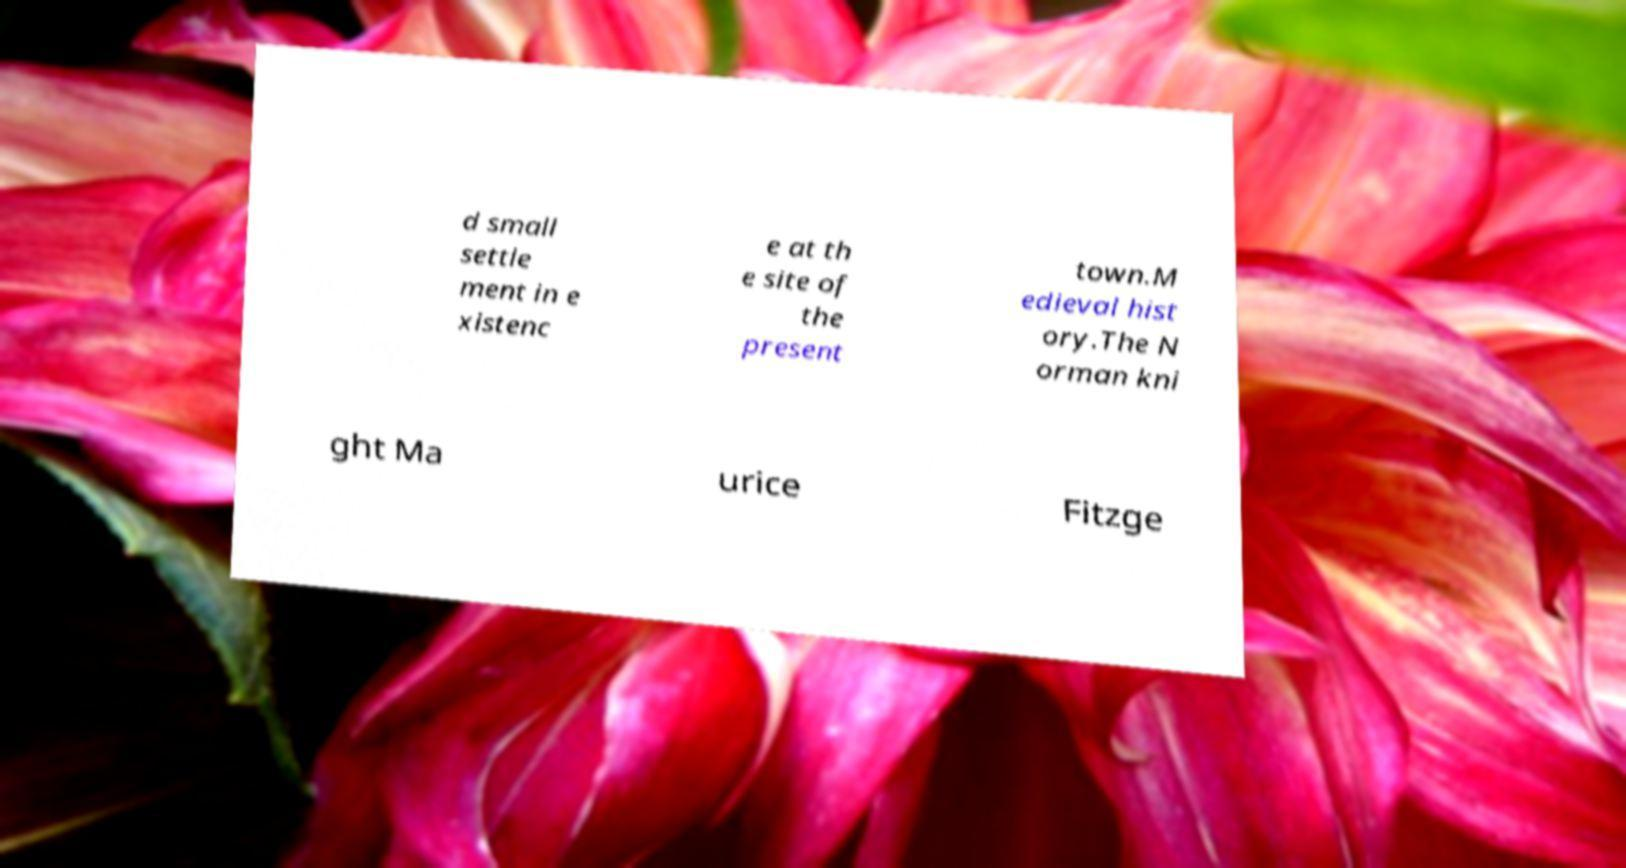What messages or text are displayed in this image? I need them in a readable, typed format. d small settle ment in e xistenc e at th e site of the present town.M edieval hist ory.The N orman kni ght Ma urice Fitzge 